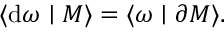Convert formula to latex. <formula><loc_0><loc_0><loc_500><loc_500>\langle d \omega | M \rangle = \langle \omega | \partial M \rangle .</formula> 